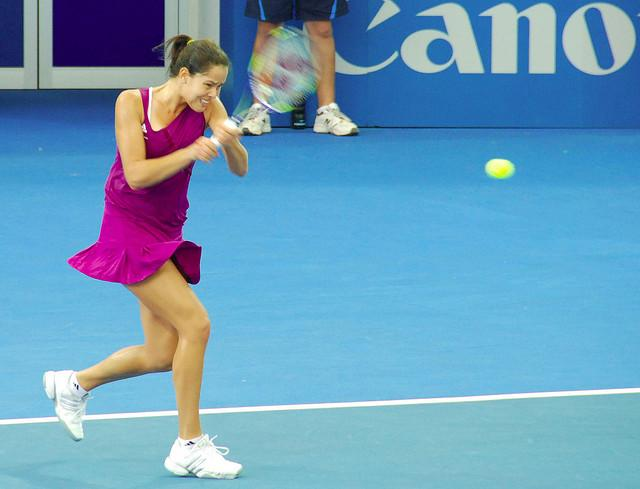What is the most likely reason for the word appearing on the wall behind the athlete?

Choices:
A) paid advertisement
B) player name
C) instructions
D) tournament name paid advertisement 